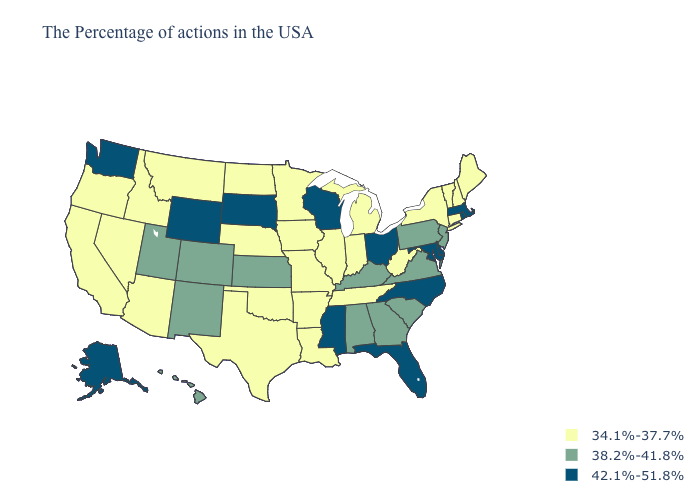What is the value of North Dakota?
Give a very brief answer. 34.1%-37.7%. What is the highest value in the MidWest ?
Short answer required. 42.1%-51.8%. What is the value of Indiana?
Give a very brief answer. 34.1%-37.7%. What is the lowest value in states that border Alabama?
Answer briefly. 34.1%-37.7%. Which states have the lowest value in the MidWest?
Concise answer only. Michigan, Indiana, Illinois, Missouri, Minnesota, Iowa, Nebraska, North Dakota. Which states have the highest value in the USA?
Short answer required. Massachusetts, Rhode Island, Delaware, Maryland, North Carolina, Ohio, Florida, Wisconsin, Mississippi, South Dakota, Wyoming, Washington, Alaska. What is the value of Mississippi?
Answer briefly. 42.1%-51.8%. Does Montana have the lowest value in the West?
Short answer required. Yes. Is the legend a continuous bar?
Keep it brief. No. What is the lowest value in the USA?
Be succinct. 34.1%-37.7%. Does South Dakota have the same value as West Virginia?
Answer briefly. No. Among the states that border South Carolina , does Georgia have the highest value?
Short answer required. No. Among the states that border New York , does Massachusetts have the lowest value?
Be succinct. No. What is the value of Wisconsin?
Quick response, please. 42.1%-51.8%. What is the value of Idaho?
Concise answer only. 34.1%-37.7%. 